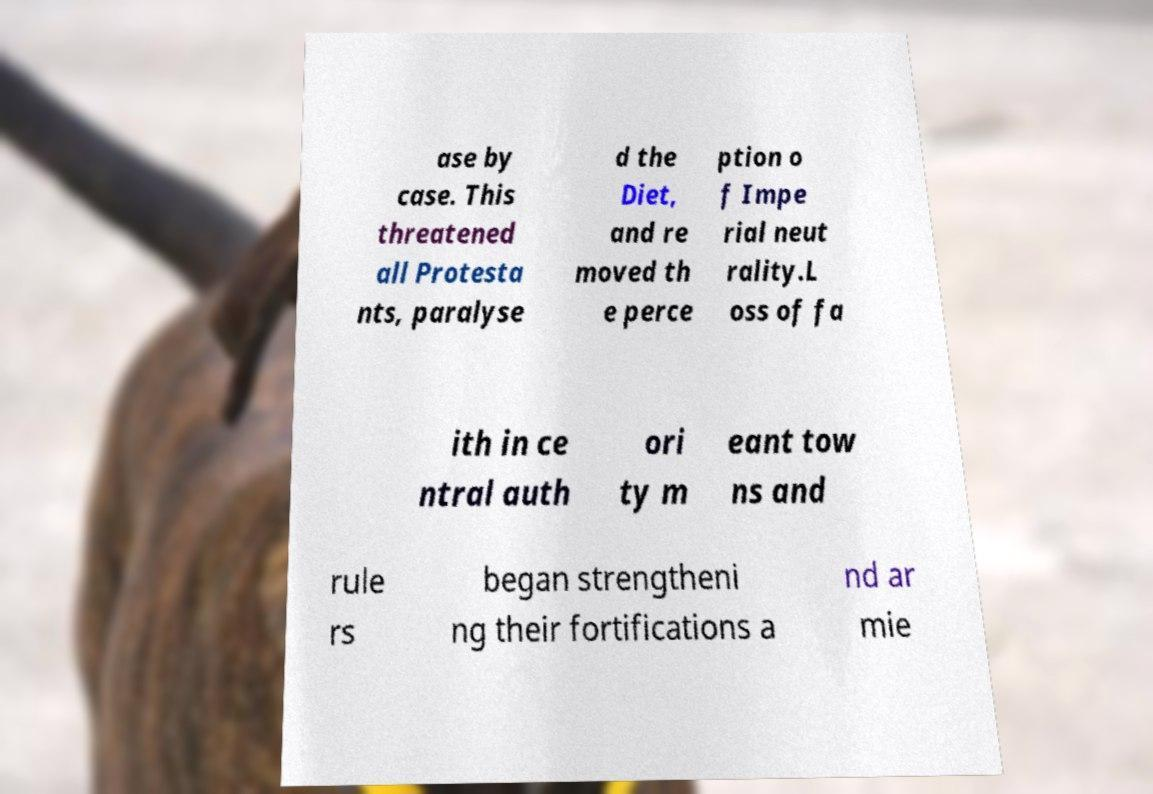For documentation purposes, I need the text within this image transcribed. Could you provide that? ase by case. This threatened all Protesta nts, paralyse d the Diet, and re moved th e perce ption o f Impe rial neut rality.L oss of fa ith in ce ntral auth ori ty m eant tow ns and rule rs began strengtheni ng their fortifications a nd ar mie 